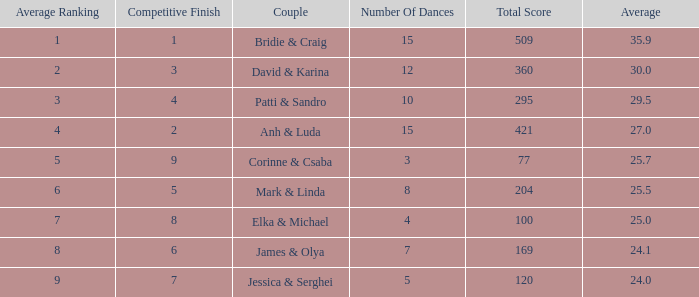Which pair has a combined score of 295? Patti & Sandro. 